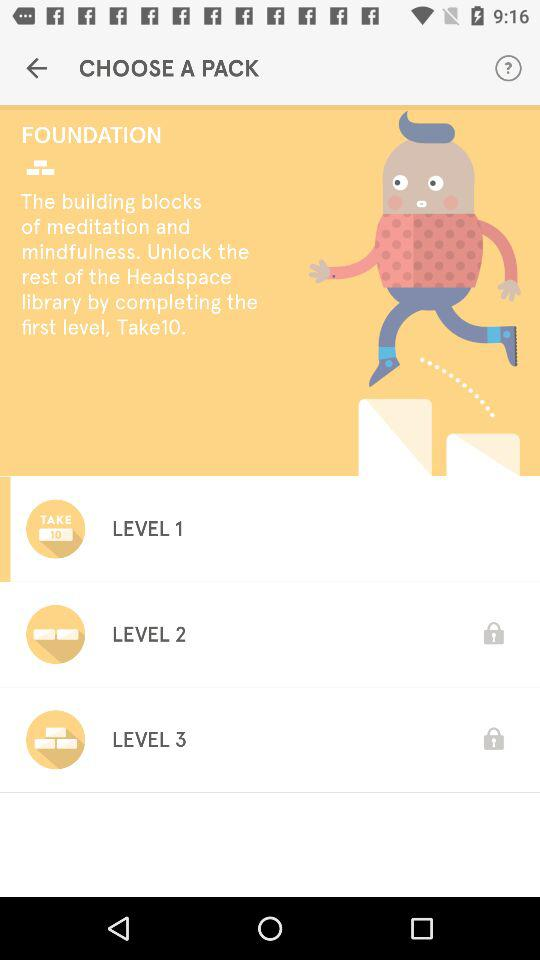What's the take number for level 1? The number is 10. 